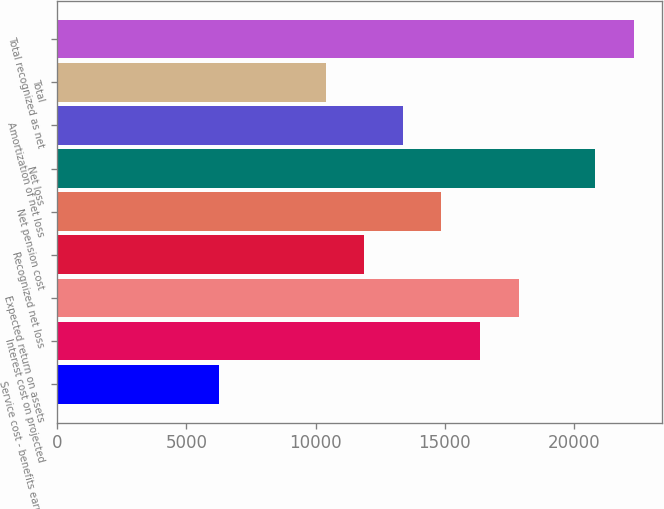Convert chart. <chart><loc_0><loc_0><loc_500><loc_500><bar_chart><fcel>Service cost - benefits earned<fcel>Interest cost on projected<fcel>Expected return on assets<fcel>Recognized net loss<fcel>Net pension cost<fcel>Net loss<fcel>Amortization of net loss<fcel>Total<fcel>Total recognized as net<nl><fcel>6263<fcel>16364<fcel>17857.5<fcel>11883.5<fcel>14870.5<fcel>20805<fcel>13377<fcel>10390<fcel>22298.5<nl></chart> 